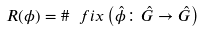Convert formula to latex. <formula><loc_0><loc_0><loc_500><loc_500>R ( \phi ) = \# \ f i x \left ( \hat { \phi } \colon \hat { G } \rightarrow \hat { G } \right )</formula> 